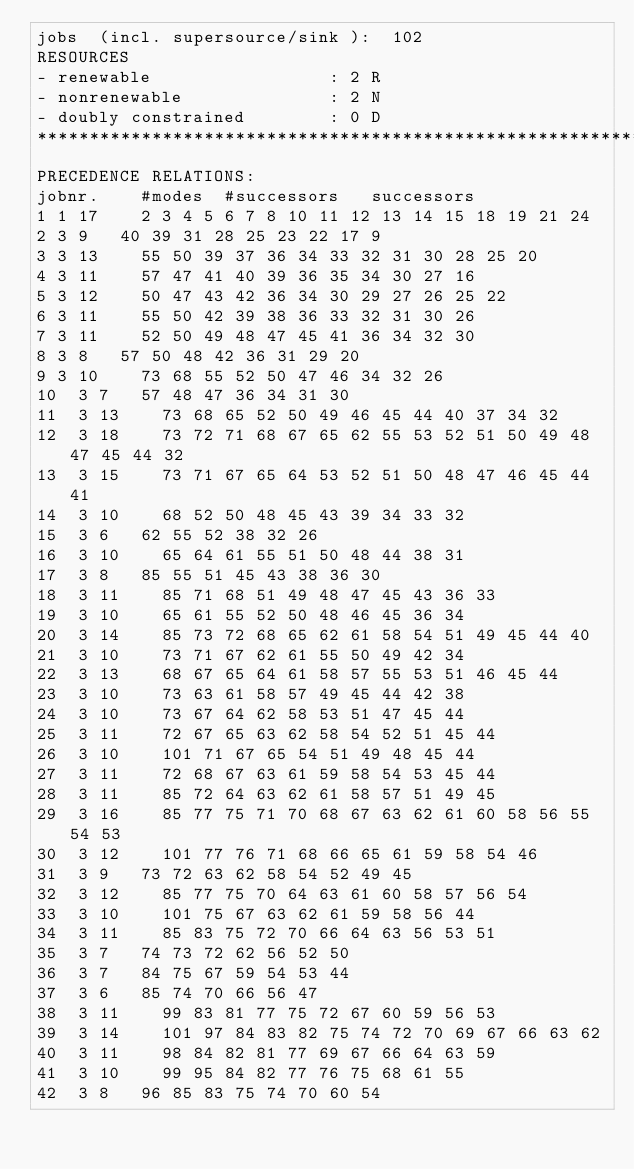<code> <loc_0><loc_0><loc_500><loc_500><_ObjectiveC_>jobs  (incl. supersource/sink ):	102
RESOURCES
- renewable                 : 2 R
- nonrenewable              : 2 N
- doubly constrained        : 0 D
************************************************************************
PRECEDENCE RELATIONS:
jobnr.    #modes  #successors   successors
1	1	17		2 3 4 5 6 7 8 10 11 12 13 14 15 18 19 21 24 
2	3	9		40 39 31 28 25 23 22 17 9 
3	3	13		55 50 39 37 36 34 33 32 31 30 28 25 20 
4	3	11		57 47 41 40 39 36 35 34 30 27 16 
5	3	12		50 47 43 42 36 34 30 29 27 26 25 22 
6	3	11		55 50 42 39 38 36 33 32 31 30 26 
7	3	11		52 50 49 48 47 45 41 36 34 32 30 
8	3	8		57 50 48 42 36 31 29 20 
9	3	10		73 68 55 52 50 47 46 34 32 26 
10	3	7		57 48 47 36 34 31 30 
11	3	13		73 68 65 52 50 49 46 45 44 40 37 34 32 
12	3	18		73 72 71 68 67 65 62 55 53 52 51 50 49 48 47 45 44 32 
13	3	15		73 71 67 65 64 53 52 51 50 48 47 46 45 44 41 
14	3	10		68 52 50 48 45 43 39 34 33 32 
15	3	6		62 55 52 38 32 26 
16	3	10		65 64 61 55 51 50 48 44 38 31 
17	3	8		85 55 51 45 43 38 36 30 
18	3	11		85 71 68 51 49 48 47 45 43 36 33 
19	3	10		65 61 55 52 50 48 46 45 36 34 
20	3	14		85 73 72 68 65 62 61 58 54 51 49 45 44 40 
21	3	10		73 71 67 62 61 55 50 49 42 34 
22	3	13		68 67 65 64 61 58 57 55 53 51 46 45 44 
23	3	10		73 63 61 58 57 49 45 44 42 38 
24	3	10		73 67 64 62 58 53 51 47 45 44 
25	3	11		72 67 65 63 62 58 54 52 51 45 44 
26	3	10		101 71 67 65 54 51 49 48 45 44 
27	3	11		72 68 67 63 61 59 58 54 53 45 44 
28	3	11		85 72 64 63 62 61 58 57 51 49 45 
29	3	16		85 77 75 71 70 68 67 63 62 61 60 58 56 55 54 53 
30	3	12		101 77 76 71 68 66 65 61 59 58 54 46 
31	3	9		73 72 63 62 58 54 52 49 45 
32	3	12		85 77 75 70 64 63 61 60 58 57 56 54 
33	3	10		101 75 67 63 62 61 59 58 56 44 
34	3	11		85 83 75 72 70 66 64 63 56 53 51 
35	3	7		74 73 72 62 56 52 50 
36	3	7		84 75 67 59 54 53 44 
37	3	6		85 74 70 66 56 47 
38	3	11		99 83 81 77 75 72 67 60 59 56 53 
39	3	14		101 97 84 83 82 75 74 72 70 69 67 66 63 62 
40	3	11		98 84 82 81 77 69 67 66 64 63 59 
41	3	10		99 95 84 82 77 76 75 68 61 55 
42	3	8		96 85 83 75 74 70 60 54 </code> 